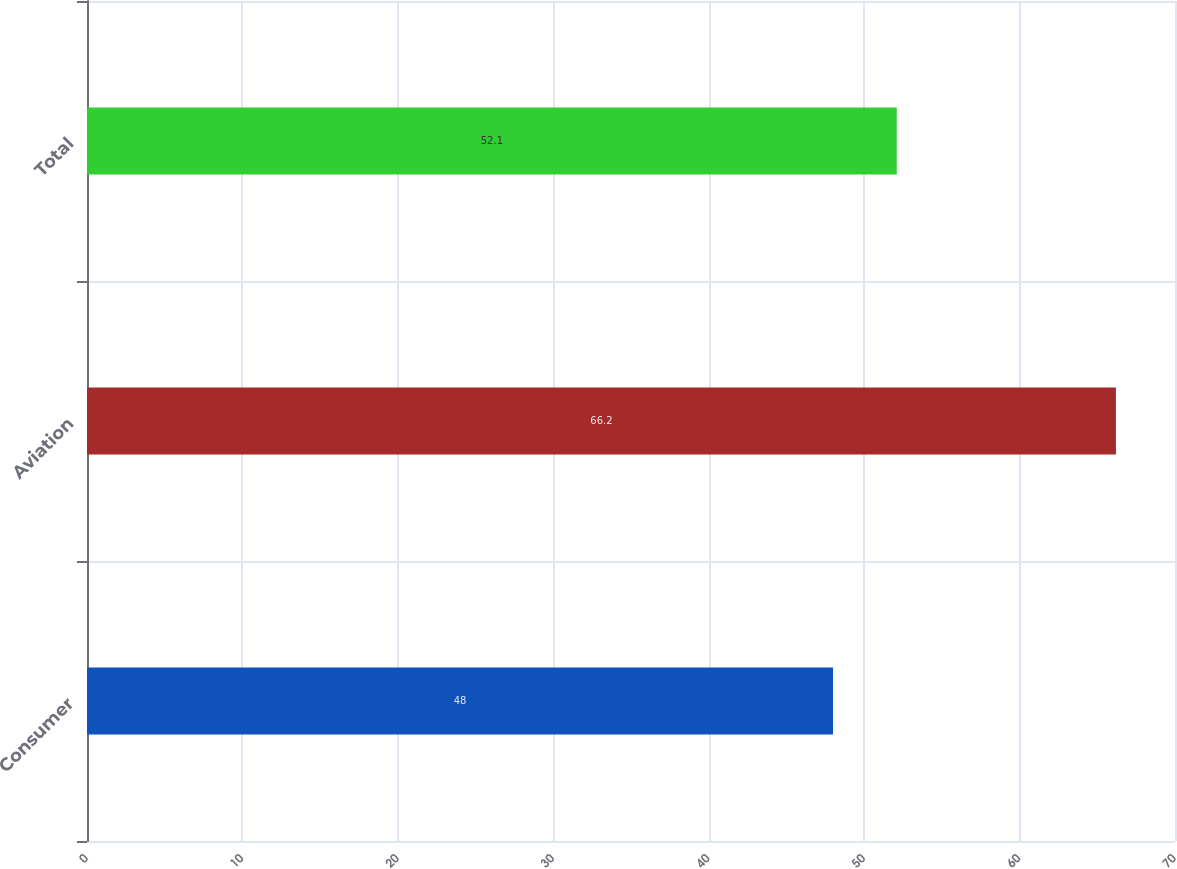Convert chart to OTSL. <chart><loc_0><loc_0><loc_500><loc_500><bar_chart><fcel>Consumer<fcel>Aviation<fcel>Total<nl><fcel>48<fcel>66.2<fcel>52.1<nl></chart> 